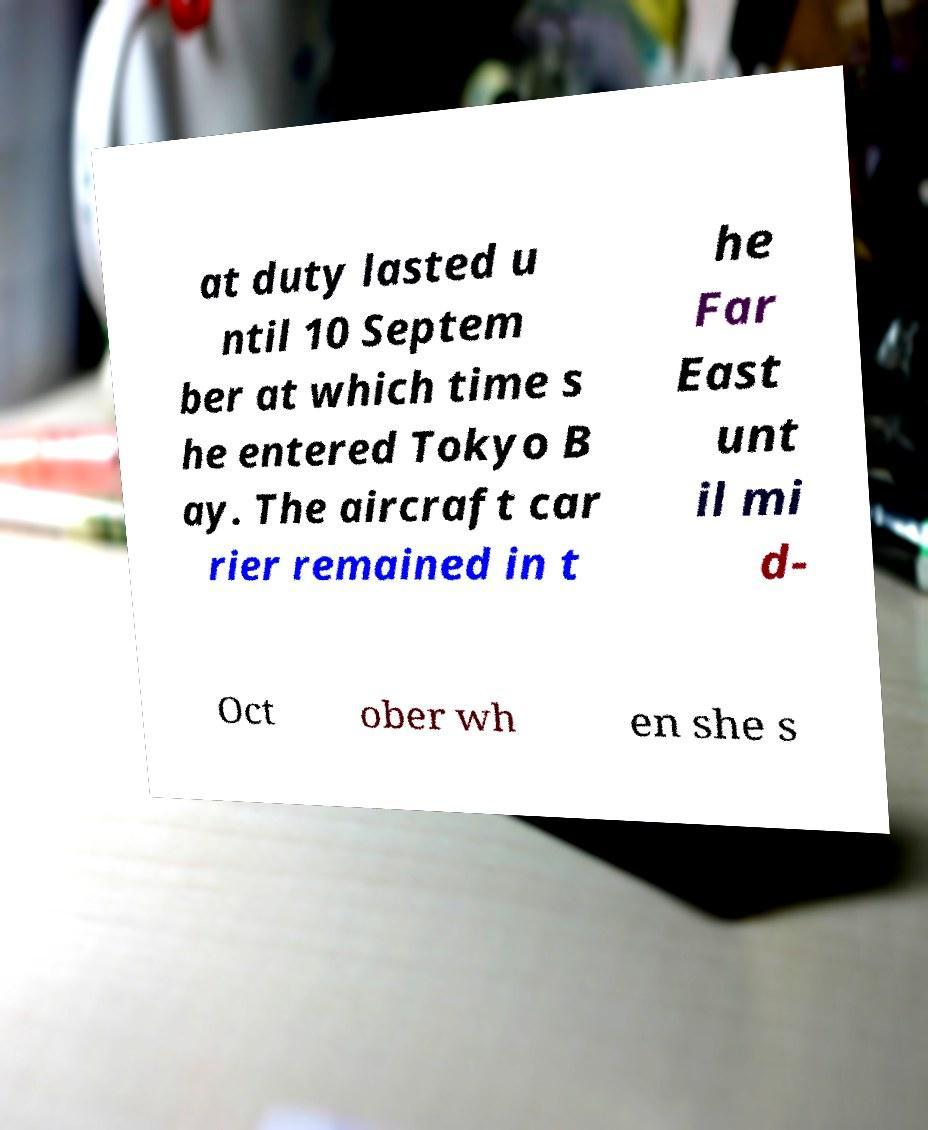For documentation purposes, I need the text within this image transcribed. Could you provide that? at duty lasted u ntil 10 Septem ber at which time s he entered Tokyo B ay. The aircraft car rier remained in t he Far East unt il mi d- Oct ober wh en she s 